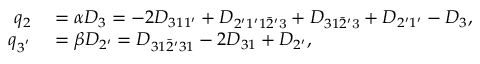<formula> <loc_0><loc_0><loc_500><loc_500>\begin{array} { r l } { q _ { 2 } } & = \alpha { D _ { 3 } } = - 2 { D _ { 3 1 1 ^ { \prime } } } + { D _ { 2 ^ { \prime } 1 ^ { \prime } 1 \bar { 2 } ^ { \prime } { 3 } } } + { D _ { 3 1 \bar { 2 } ^ { \prime } { 3 } } } + { D _ { 2 ^ { \prime } 1 ^ { \prime } } } - { D _ { 3 } } , } \\ { q _ { 3 ^ { ^ { \prime } } } } & = \beta { D _ { 2 ^ { \prime } } } = { D _ { 3 1 \bar { 2 } ^ { \prime } 3 1 } } - 2 { D _ { 3 1 } } + { D _ { 2 ^ { \prime } } } , } \end{array}</formula> 